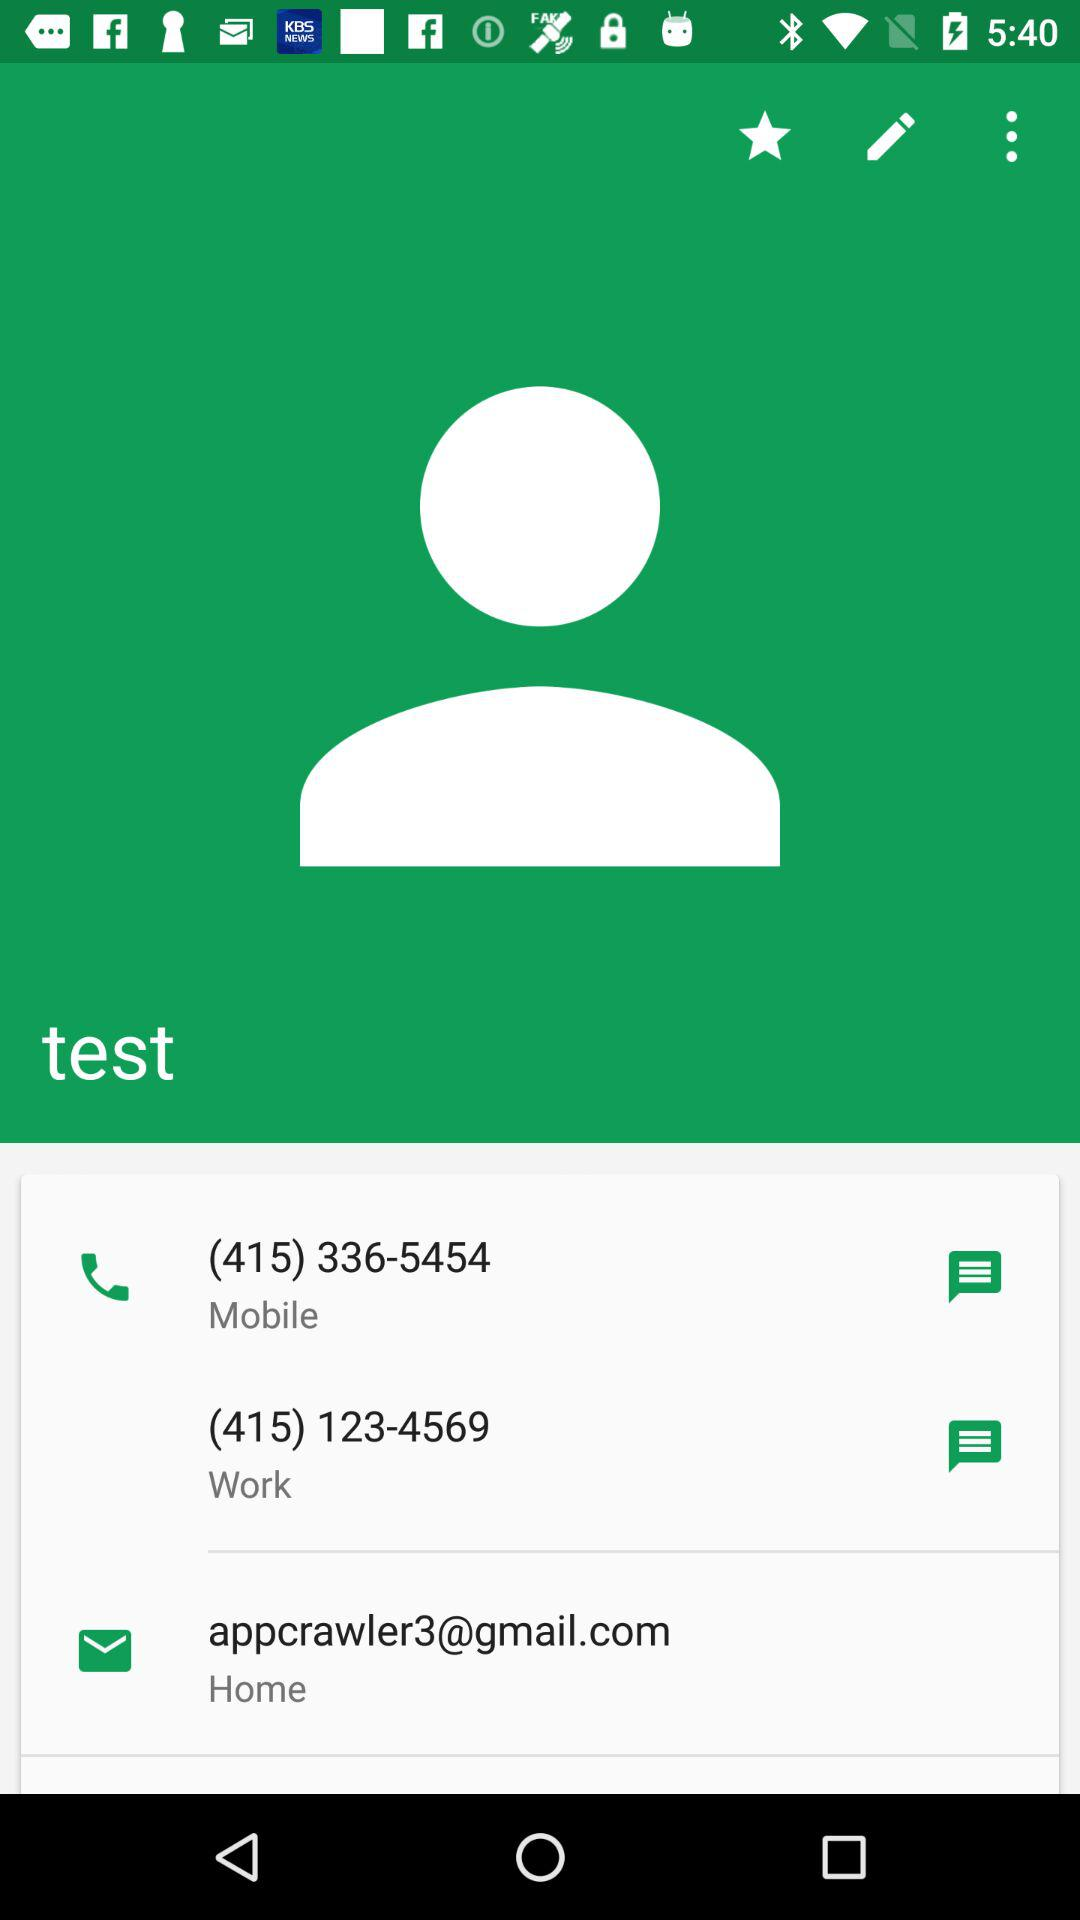What is the work number? The work number is (415) 123-4569. 